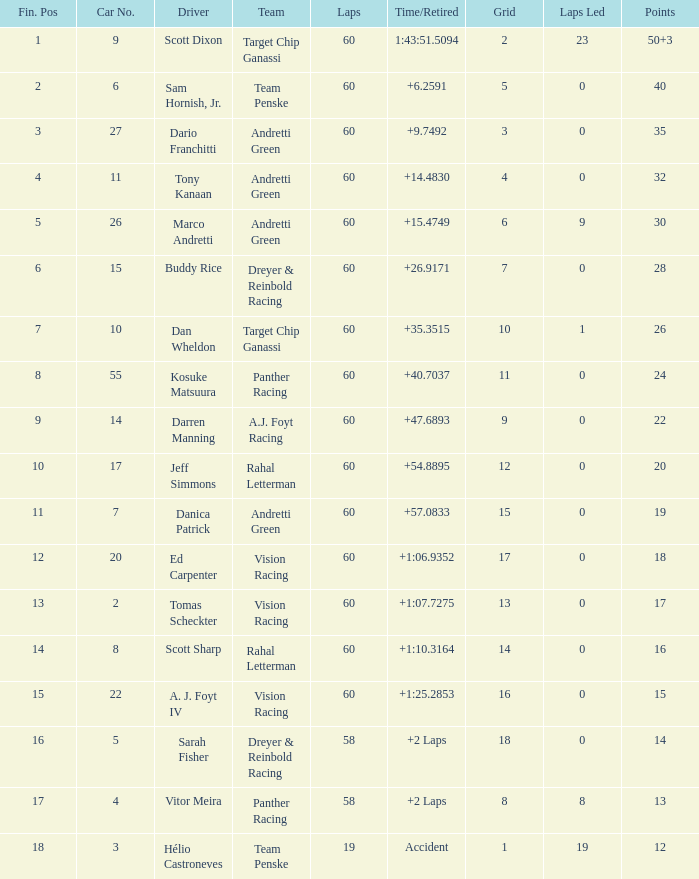Identify the rounds for 18 points. 60.0. 